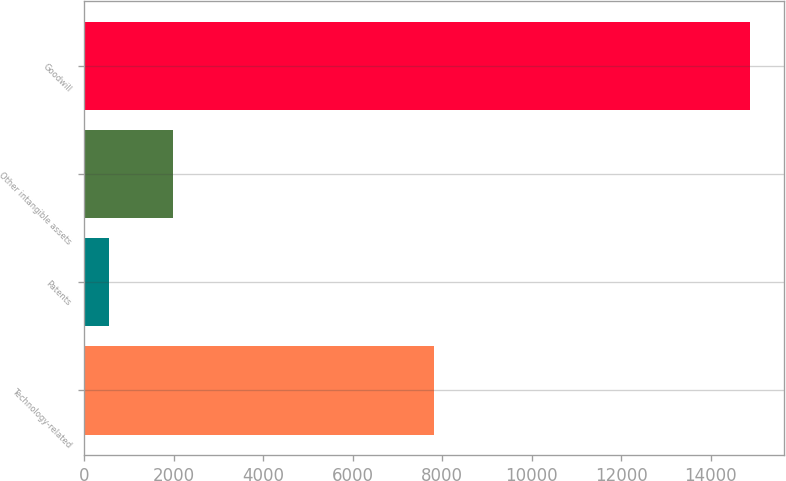<chart> <loc_0><loc_0><loc_500><loc_500><bar_chart><fcel>Technology-related<fcel>Patents<fcel>Other intangible assets<fcel>Goodwill<nl><fcel>7823<fcel>539<fcel>1973.9<fcel>14888<nl></chart> 